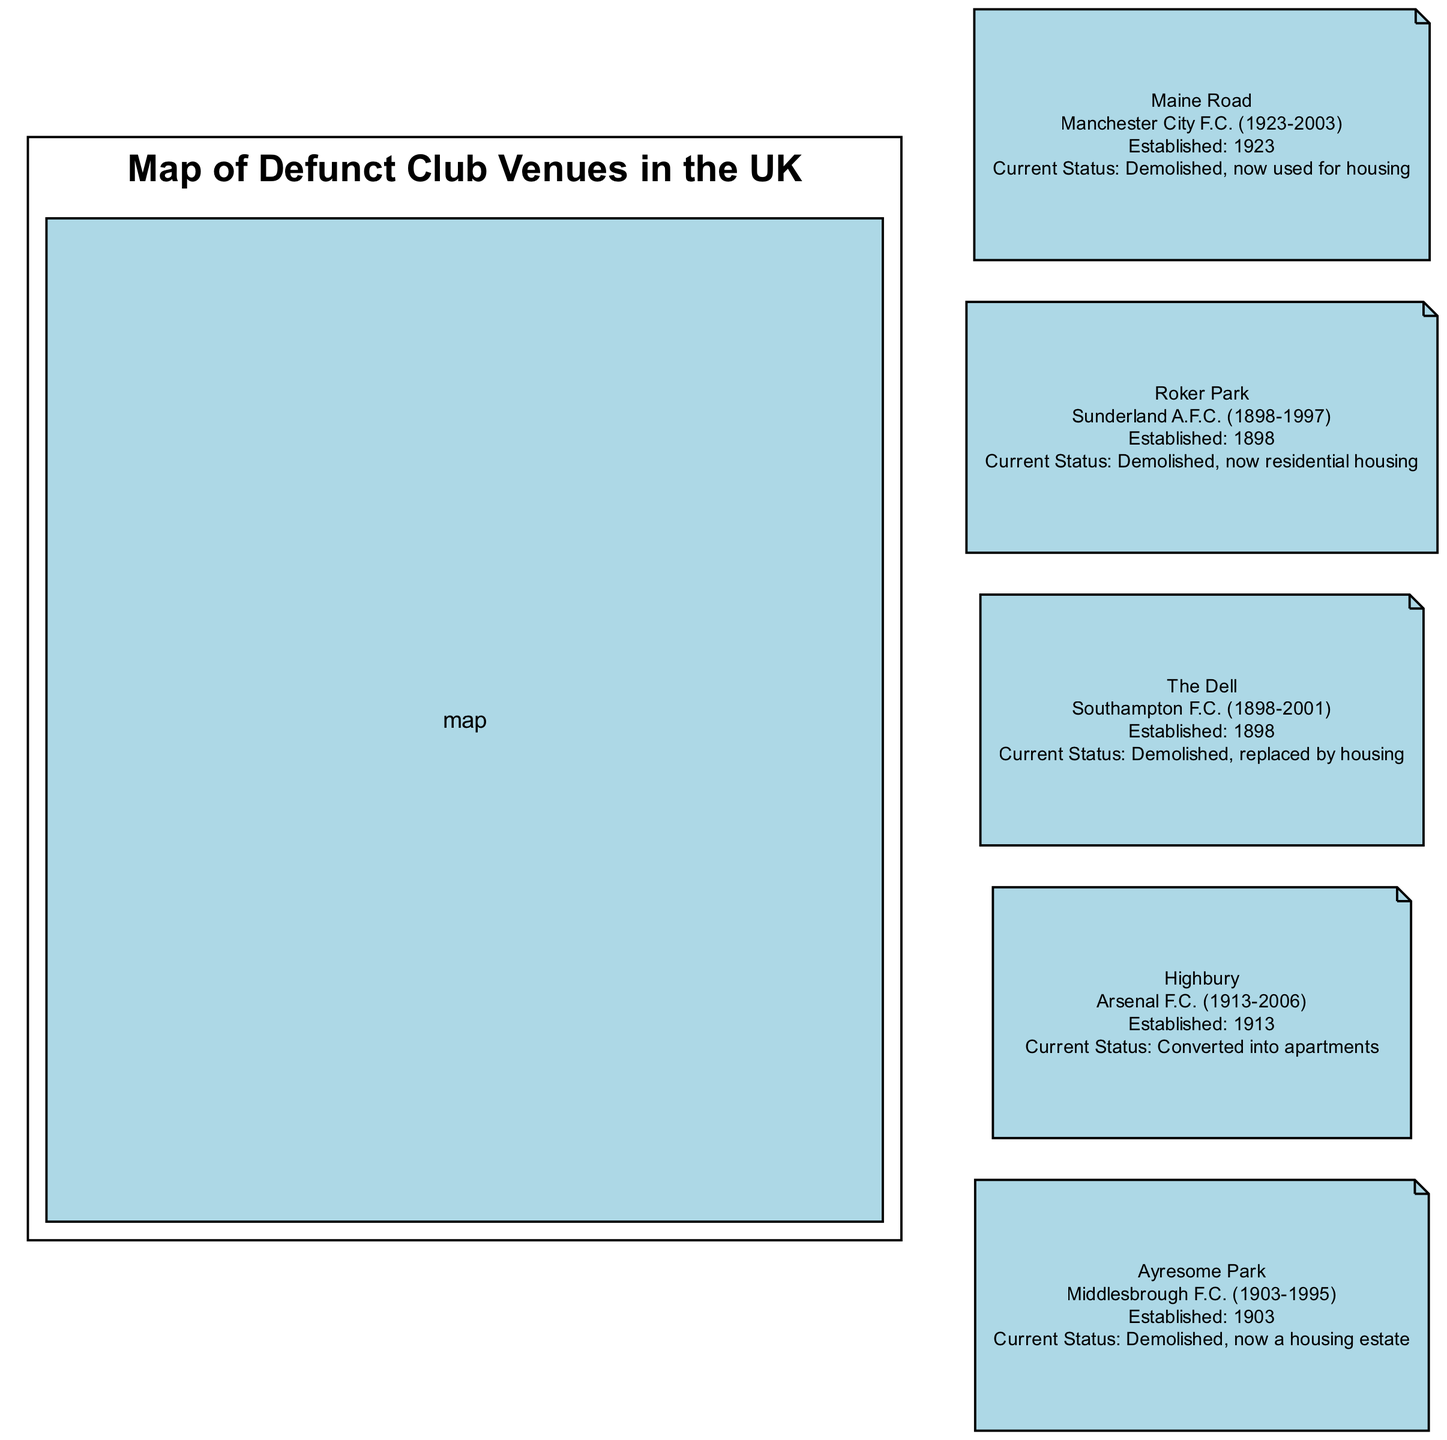What is the current status of Maine Road? According to the diagram, Maine Road is listed with a current status of "Demolished, now used for housing," which indicates that the stadium no longer exists and the site has been repurposed.
Answer: Demolished, now used for housing How many stadiums are featured in the diagram? By reviewing the diagram's elements, there are a total of five stadiums representing defunct clubs. Each stadium is clearly listed and described in the diagram.
Answer: 5 Which year was Roker Park established? The diagram specifies that Roker Park was established in the year 1898 as indicated in its description, which includes the years of operation for the relevant club.
Answer: 1898 What club used The Dell as their home ground? The Dell is associated with Southampton F.C., as mentioned in its description. This indicates the club that played at this venue during its operational years.
Answer: Southampton F.C Which stadium was converted into apartments? According to the diagram, Highbury is noted as having been converted into apartments, which is part of its status section in the annotated information provided.
Answer: Converted into apartments Which two stadiums were established in the same year? Both Roker Park and The Dell were established in 1898, as the diagram shows their establishment years, indicating they have the same inception date.
Answer: Roker Park and The Dell What is the main description of Ayresome Park? The diagram provides that Ayresome Park was the home ground for Middlesbrough F.C. from 1903 to 1995, giving a clear overview of its historical significance.
Answer: Middlesbrough F.C. (1903-1995) Which stadium is now a housing estate? The diagram indicates that Ayresome Park is now a housing estate, as referenced in its current status description.
Answer: Ayresome Park What is the geographical focus of the diagram? The diagram's title and the presence of location markers suggest that it focuses specifically on the United Kingdom, highlighting the locations of defunct club venues across the country.
Answer: United Kingdom 